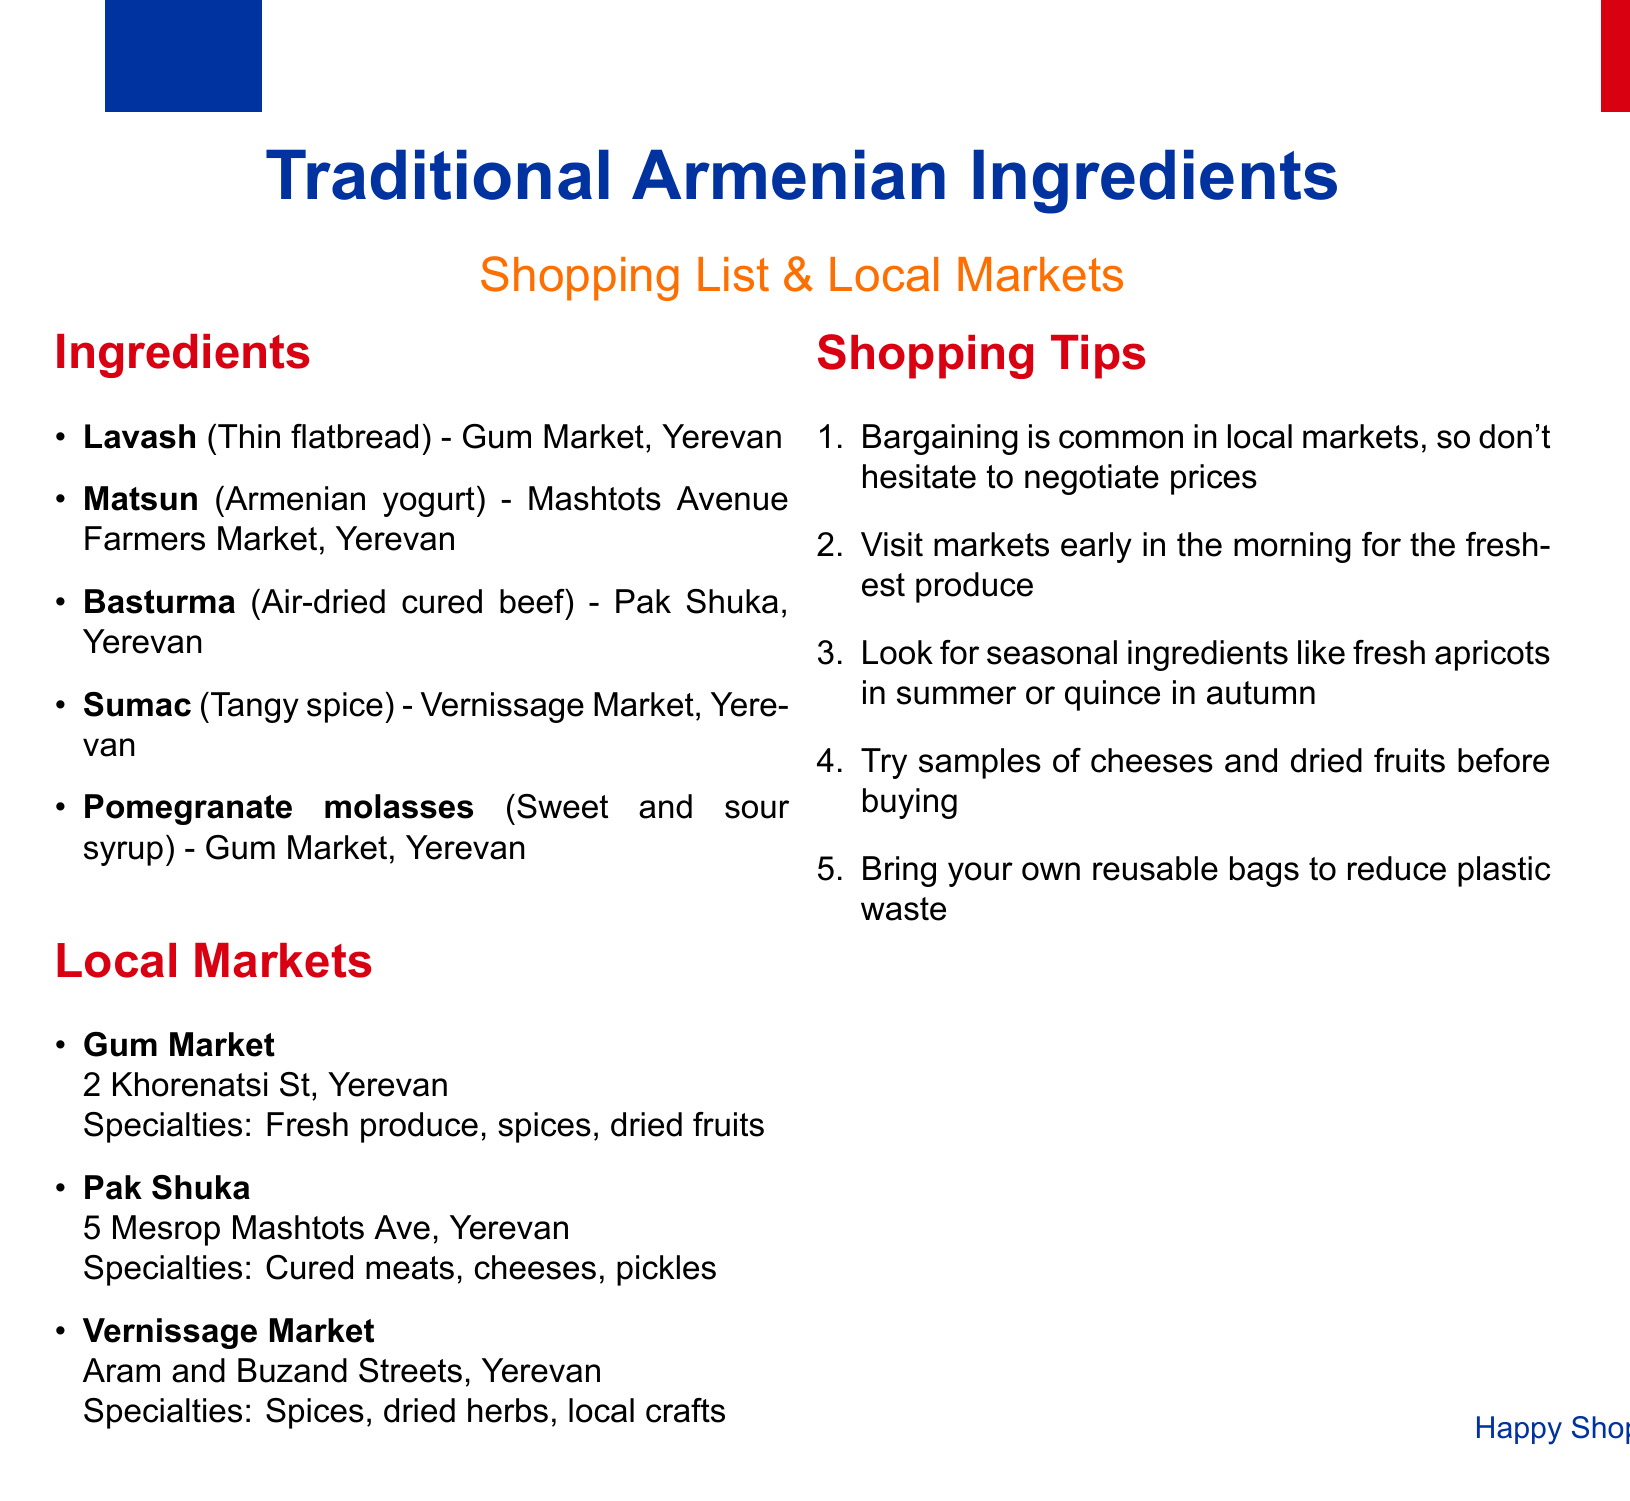What is the first ingredient listed? The first ingredient mentioned in the list is Lavash, which is a thin flatbread.
Answer: Lavash Where can you find Matsun? Matsun, Armenian yogurt, can be found at the Mashtots Avenue Farmers Market in Yerevan.
Answer: Mashtots Avenue Farmers Market, Yerevan What specialty is offered at Pak Shuka? Pak Shuka specializes in cured meats, cheeses, and pickles.
Answer: Cured meats, cheeses, pickles How many markets are listed in the document? The document lists three local markets where traditional ingredients can be found.
Answer: Three What is a suggested shopping tip regarding market visits? One of the tips suggests to visit markets early in the morning for the freshest produce.
Answer: Visit markets early in the morning What ingredient is associated with Gum Market? Pomegranate molasses, which is a sweet and sour syrup, is associated with Gum Market.
Answer: Pomegranate molasses What is the location of Vernissage Market? Vernissage Market is located at Aram and Buzand Streets in Yerevan.
Answer: Aram and Buzand Streets, Yerevan What should shoppers bring to reduce plastic waste? Shoppers are encouraged to bring their own reusable bags to reduce plastic waste.
Answer: Reusable bags Which ingredient is a tangy spice? The ingredient listed as a tangy spice is Sumac.
Answer: Sumac 